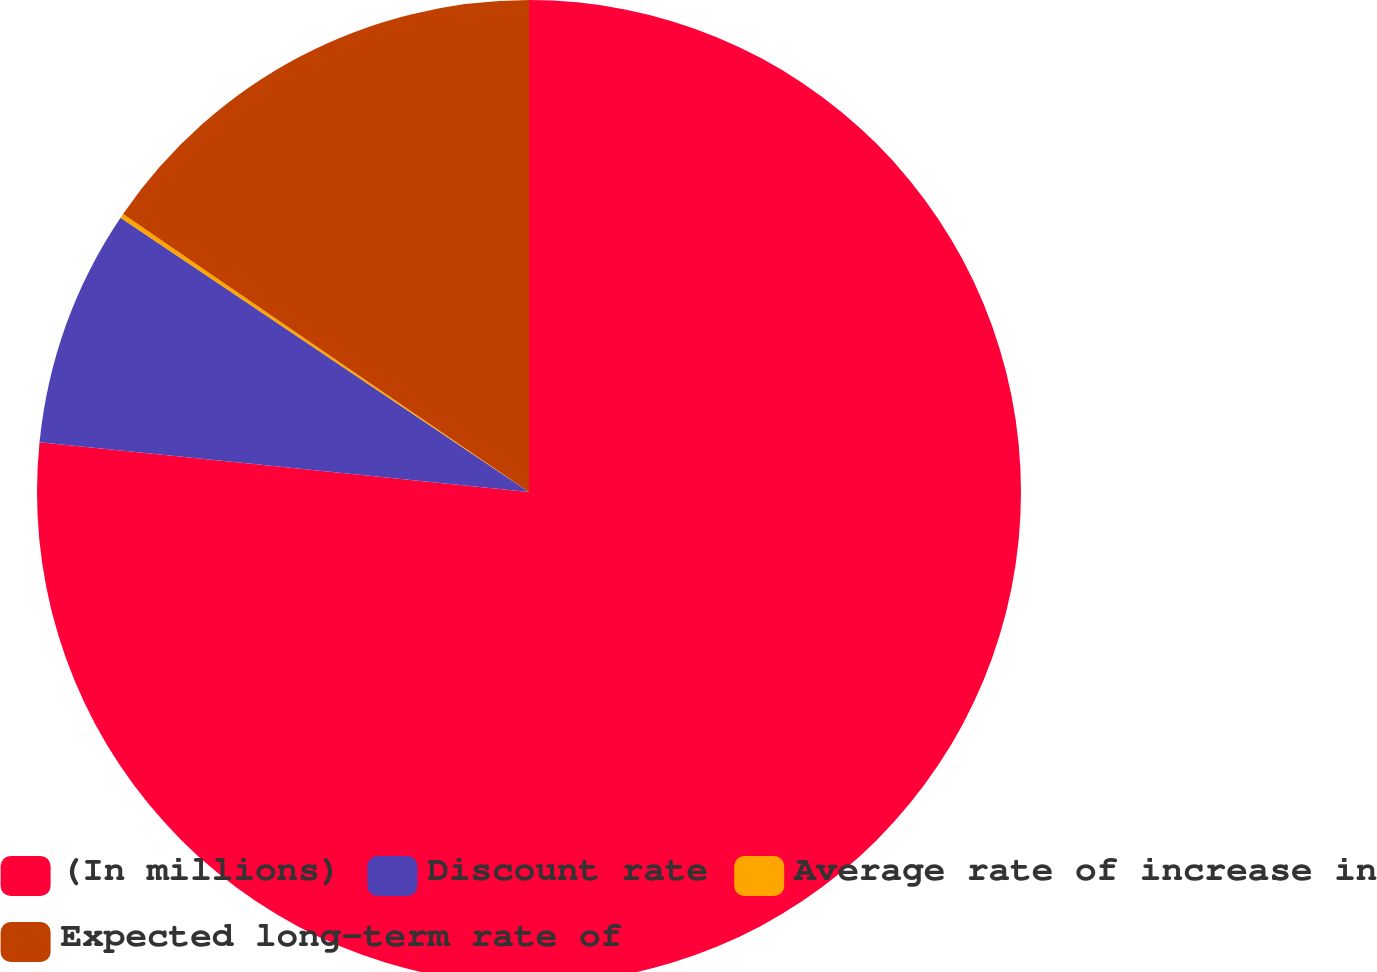<chart> <loc_0><loc_0><loc_500><loc_500><pie_chart><fcel>(In millions)<fcel>Discount rate<fcel>Average rate of increase in<fcel>Expected long-term rate of<nl><fcel>76.61%<fcel>7.8%<fcel>0.15%<fcel>15.44%<nl></chart> 